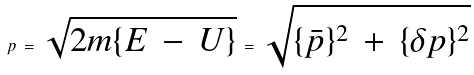<formula> <loc_0><loc_0><loc_500><loc_500>p \, = \, \sqrt { 2 m \{ E \, - \, U \} } \, = \, \sqrt { \{ \bar { p } \} ^ { 2 } \, + \, \{ \delta p \} ^ { 2 } } \,</formula> 